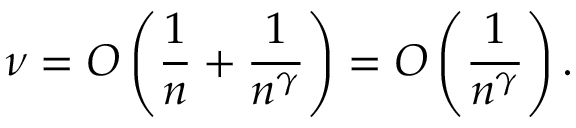<formula> <loc_0><loc_0><loc_500><loc_500>\nu = O \left ( \frac { 1 } { n } + \frac { 1 } { n ^ { \gamma } } \right ) = O \left ( \frac { 1 } { n ^ { \gamma } } \right ) .</formula> 